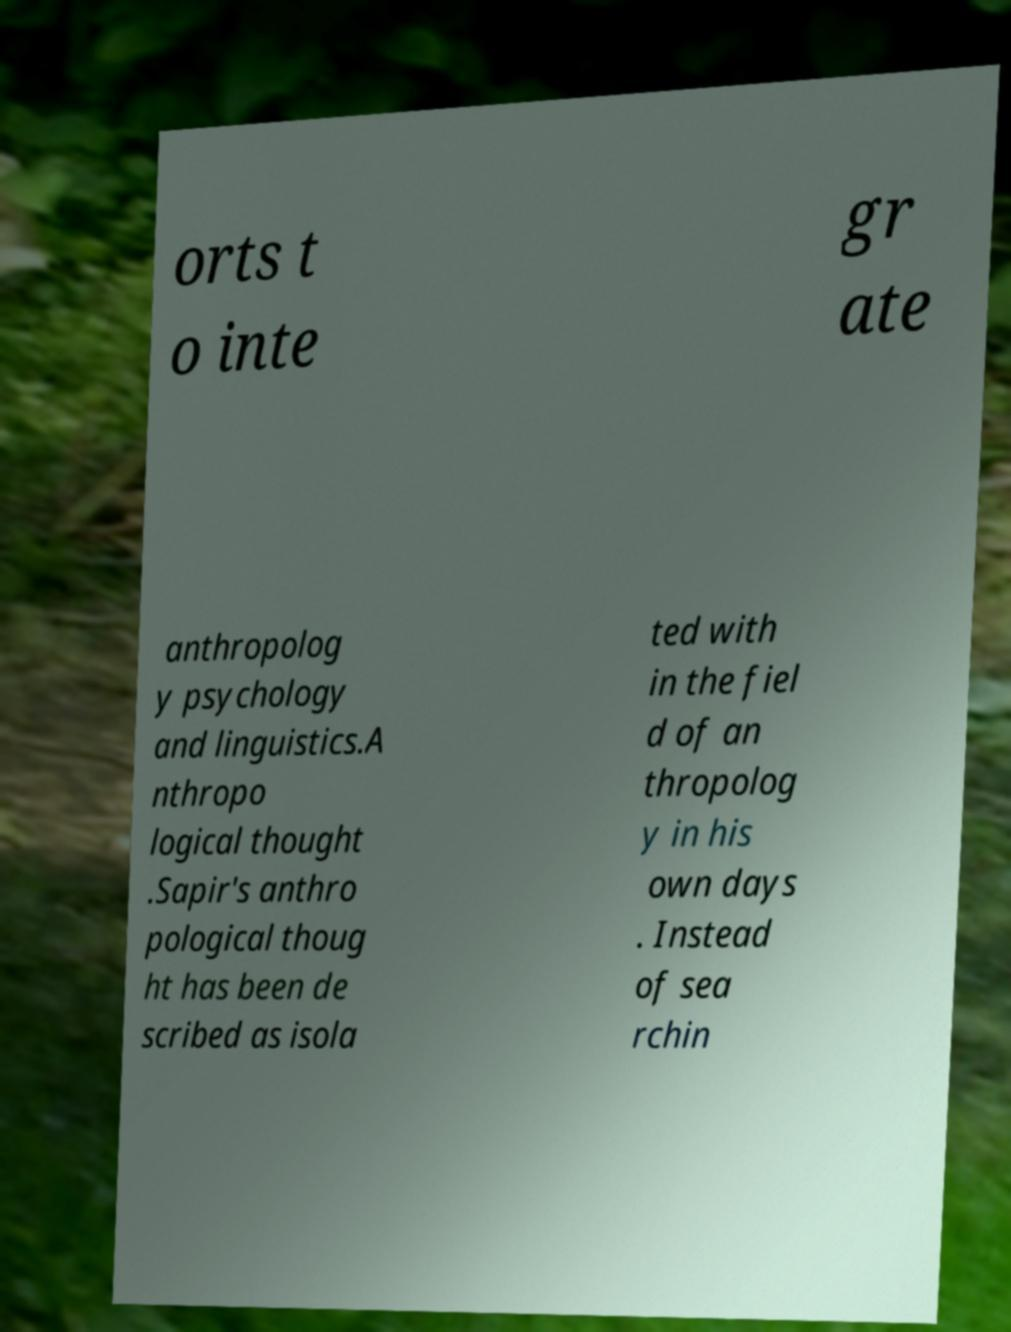There's text embedded in this image that I need extracted. Can you transcribe it verbatim? orts t o inte gr ate anthropolog y psychology and linguistics.A nthropo logical thought .Sapir's anthro pological thoug ht has been de scribed as isola ted with in the fiel d of an thropolog y in his own days . Instead of sea rchin 